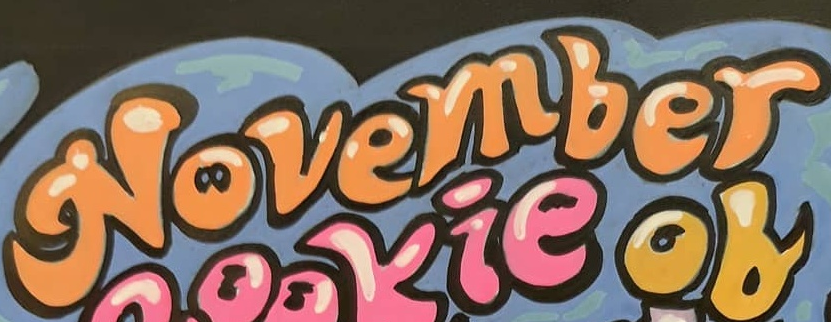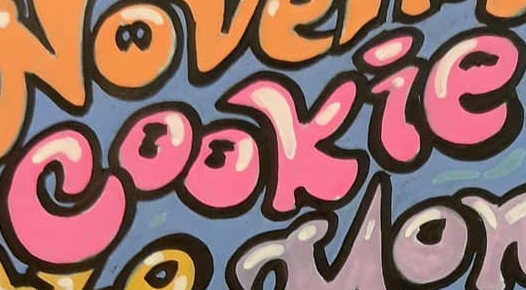Transcribe the words shown in these images in order, separated by a semicolon. November; cookie 